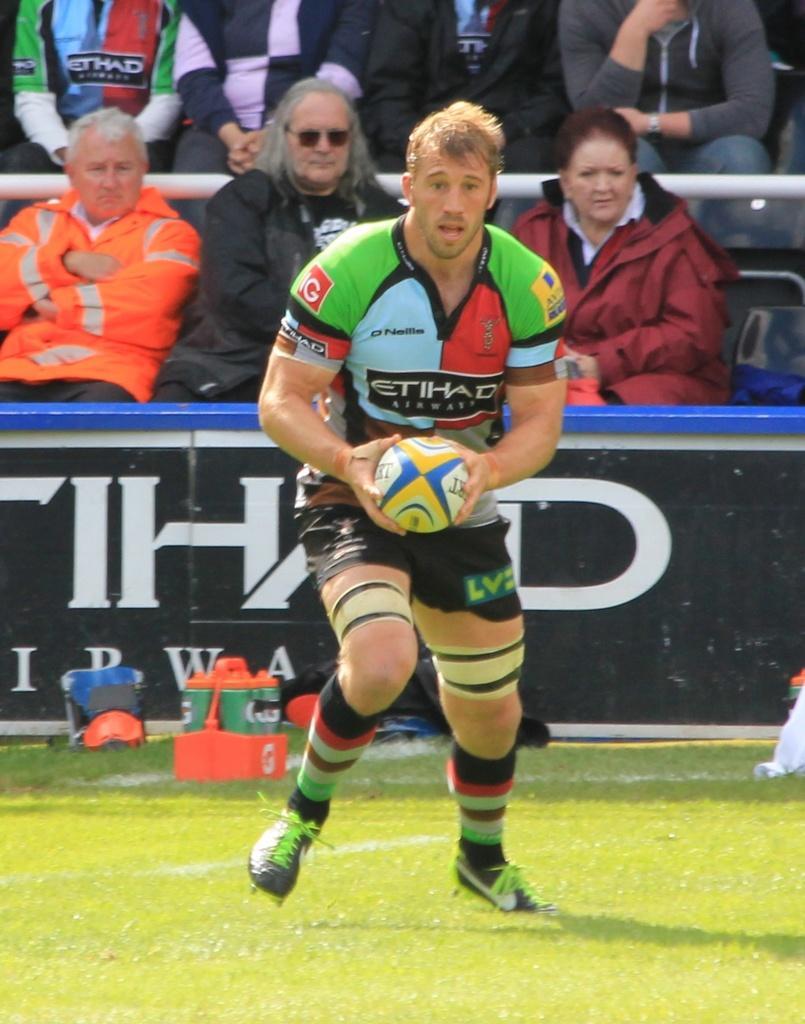Could you give a brief overview of what you see in this image? This image consists of a man playing a game. He is wearing a jersey. At the bottom, there is green grass. In the background, there are many people sitting in the chairs. 